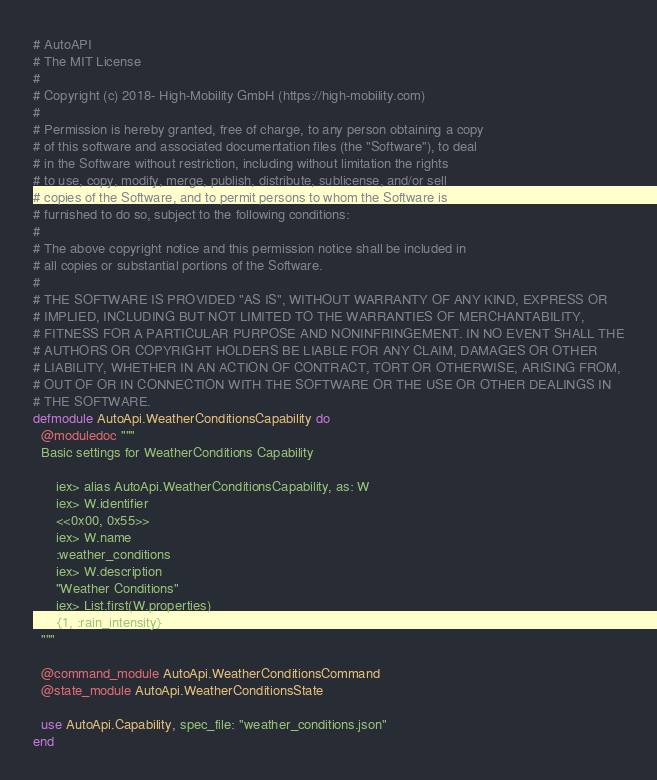<code> <loc_0><loc_0><loc_500><loc_500><_Elixir_># AutoAPI
# The MIT License
#
# Copyright (c) 2018- High-Mobility GmbH (https://high-mobility.com)
#
# Permission is hereby granted, free of charge, to any person obtaining a copy
# of this software and associated documentation files (the "Software"), to deal
# in the Software without restriction, including without limitation the rights
# to use, copy, modify, merge, publish, distribute, sublicense, and/or sell
# copies of the Software, and to permit persons to whom the Software is
# furnished to do so, subject to the following conditions:
#
# The above copyright notice and this permission notice shall be included in
# all copies or substantial portions of the Software.
#
# THE SOFTWARE IS PROVIDED "AS IS", WITHOUT WARRANTY OF ANY KIND, EXPRESS OR
# IMPLIED, INCLUDING BUT NOT LIMITED TO THE WARRANTIES OF MERCHANTABILITY,
# FITNESS FOR A PARTICULAR PURPOSE AND NONINFRINGEMENT. IN NO EVENT SHALL THE
# AUTHORS OR COPYRIGHT HOLDERS BE LIABLE FOR ANY CLAIM, DAMAGES OR OTHER
# LIABILITY, WHETHER IN AN ACTION OF CONTRACT, TORT OR OTHERWISE, ARISING FROM,
# OUT OF OR IN CONNECTION WITH THE SOFTWARE OR THE USE OR OTHER DEALINGS IN
# THE SOFTWARE.
defmodule AutoApi.WeatherConditionsCapability do
  @moduledoc """
  Basic settings for WeatherConditions Capability

      iex> alias AutoApi.WeatherConditionsCapability, as: W
      iex> W.identifier
      <<0x00, 0x55>>
      iex> W.name
      :weather_conditions
      iex> W.description
      "Weather Conditions"
      iex> List.first(W.properties)
      {1, :rain_intensity}
  """

  @command_module AutoApi.WeatherConditionsCommand
  @state_module AutoApi.WeatherConditionsState

  use AutoApi.Capability, spec_file: "weather_conditions.json"
end
</code> 